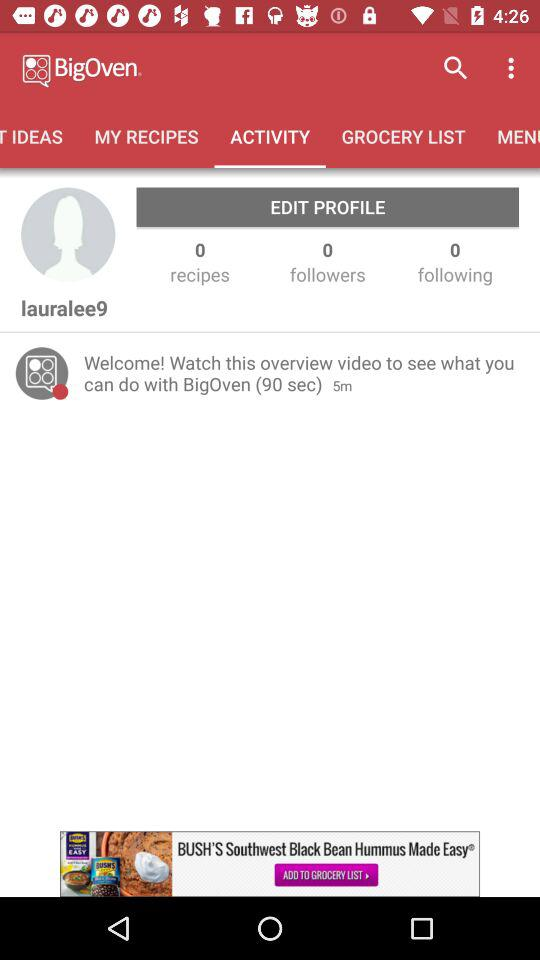How many seconds long is the overview video?
Answer the question using a single word or phrase. 90 